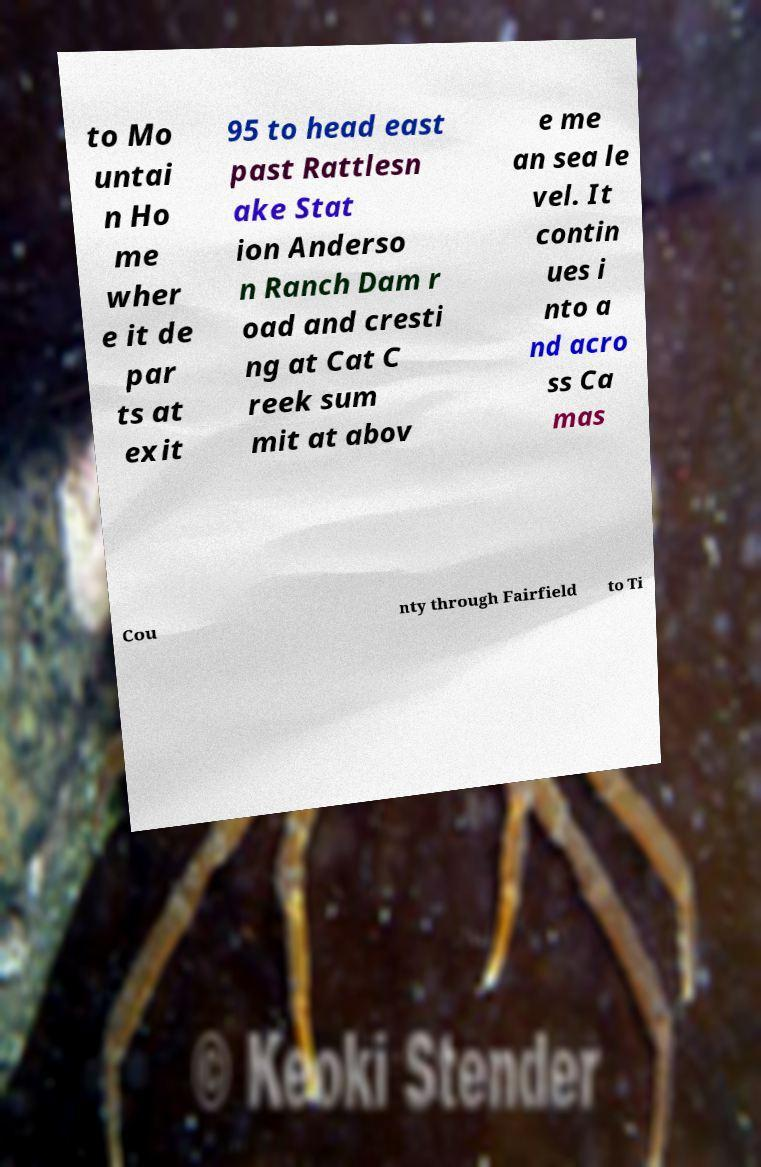I need the written content from this picture converted into text. Can you do that? to Mo untai n Ho me wher e it de par ts at exit 95 to head east past Rattlesn ake Stat ion Anderso n Ranch Dam r oad and cresti ng at Cat C reek sum mit at abov e me an sea le vel. It contin ues i nto a nd acro ss Ca mas Cou nty through Fairfield to Ti 